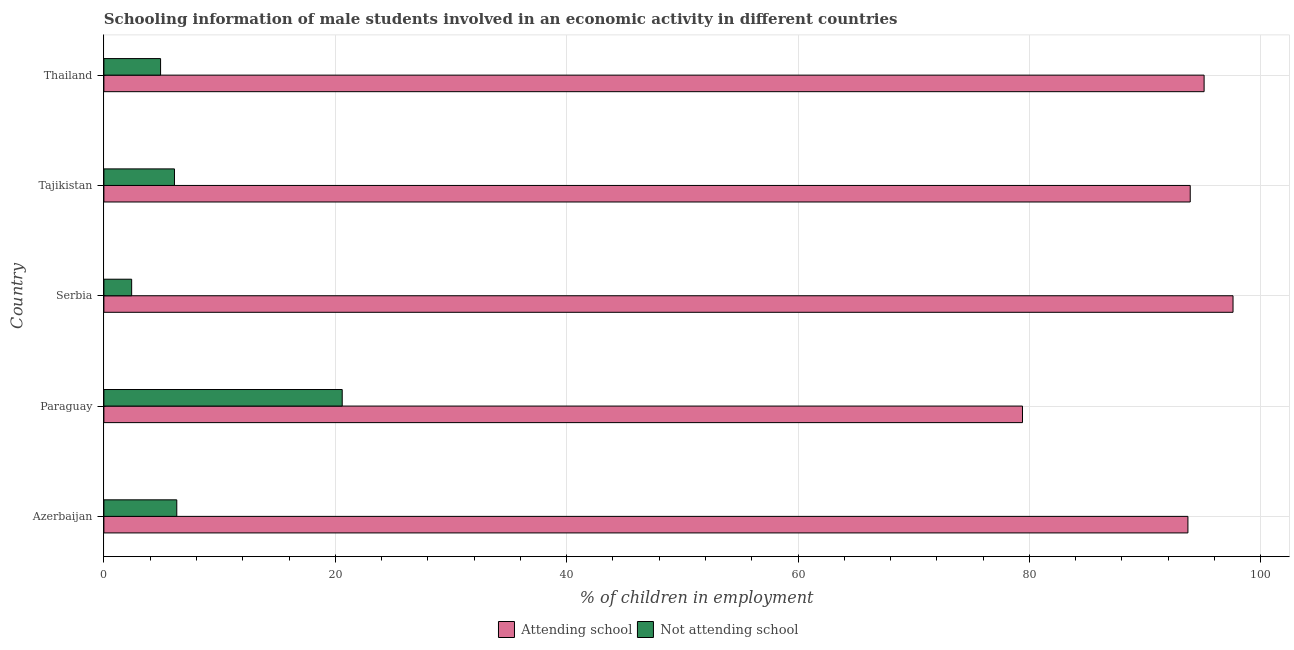How many different coloured bars are there?
Ensure brevity in your answer.  2. How many groups of bars are there?
Offer a terse response. 5. Are the number of bars on each tick of the Y-axis equal?
Offer a very short reply. Yes. How many bars are there on the 4th tick from the bottom?
Your answer should be very brief. 2. What is the label of the 3rd group of bars from the top?
Your response must be concise. Serbia. What is the percentage of employed males who are attending school in Azerbaijan?
Ensure brevity in your answer.  93.7. Across all countries, what is the maximum percentage of employed males who are not attending school?
Ensure brevity in your answer.  20.6. Across all countries, what is the minimum percentage of employed males who are attending school?
Offer a terse response. 79.4. In which country was the percentage of employed males who are attending school maximum?
Provide a succinct answer. Serbia. In which country was the percentage of employed males who are not attending school minimum?
Ensure brevity in your answer.  Serbia. What is the total percentage of employed males who are attending school in the graph?
Ensure brevity in your answer.  459.7. What is the difference between the percentage of employed males who are attending school in Azerbaijan and that in Tajikistan?
Offer a terse response. -0.2. What is the difference between the percentage of employed males who are not attending school in Azerbaijan and the percentage of employed males who are attending school in Paraguay?
Give a very brief answer. -73.1. What is the average percentage of employed males who are attending school per country?
Offer a terse response. 91.94. What is the difference between the percentage of employed males who are not attending school and percentage of employed males who are attending school in Tajikistan?
Provide a succinct answer. -87.8. What is the ratio of the percentage of employed males who are attending school in Paraguay to that in Serbia?
Make the answer very short. 0.81. Is the percentage of employed males who are not attending school in Azerbaijan less than that in Thailand?
Provide a succinct answer. No. In how many countries, is the percentage of employed males who are not attending school greater than the average percentage of employed males who are not attending school taken over all countries?
Provide a short and direct response. 1. What does the 2nd bar from the top in Thailand represents?
Your answer should be very brief. Attending school. What does the 2nd bar from the bottom in Azerbaijan represents?
Make the answer very short. Not attending school. How many bars are there?
Your response must be concise. 10. How many countries are there in the graph?
Your answer should be compact. 5. What is the difference between two consecutive major ticks on the X-axis?
Offer a very short reply. 20. How many legend labels are there?
Give a very brief answer. 2. How are the legend labels stacked?
Your response must be concise. Horizontal. What is the title of the graph?
Provide a succinct answer. Schooling information of male students involved in an economic activity in different countries. What is the label or title of the X-axis?
Your answer should be compact. % of children in employment. What is the % of children in employment of Attending school in Azerbaijan?
Your answer should be compact. 93.7. What is the % of children in employment of Not attending school in Azerbaijan?
Keep it short and to the point. 6.3. What is the % of children in employment in Attending school in Paraguay?
Give a very brief answer. 79.4. What is the % of children in employment of Not attending school in Paraguay?
Provide a short and direct response. 20.6. What is the % of children in employment of Attending school in Serbia?
Ensure brevity in your answer.  97.6. What is the % of children in employment in Not attending school in Serbia?
Offer a very short reply. 2.4. What is the % of children in employment in Attending school in Tajikistan?
Your answer should be very brief. 93.9. What is the % of children in employment of Attending school in Thailand?
Your response must be concise. 95.1. What is the % of children in employment of Not attending school in Thailand?
Make the answer very short. 4.9. Across all countries, what is the maximum % of children in employment of Attending school?
Offer a very short reply. 97.6. Across all countries, what is the maximum % of children in employment in Not attending school?
Ensure brevity in your answer.  20.6. Across all countries, what is the minimum % of children in employment in Attending school?
Ensure brevity in your answer.  79.4. Across all countries, what is the minimum % of children in employment in Not attending school?
Keep it short and to the point. 2.4. What is the total % of children in employment in Attending school in the graph?
Give a very brief answer. 459.7. What is the total % of children in employment in Not attending school in the graph?
Your answer should be compact. 40.3. What is the difference between the % of children in employment of Not attending school in Azerbaijan and that in Paraguay?
Your response must be concise. -14.3. What is the difference between the % of children in employment of Attending school in Azerbaijan and that in Serbia?
Offer a terse response. -3.9. What is the difference between the % of children in employment of Attending school in Azerbaijan and that in Tajikistan?
Give a very brief answer. -0.2. What is the difference between the % of children in employment of Not attending school in Azerbaijan and that in Tajikistan?
Keep it short and to the point. 0.2. What is the difference between the % of children in employment in Not attending school in Azerbaijan and that in Thailand?
Provide a succinct answer. 1.4. What is the difference between the % of children in employment of Attending school in Paraguay and that in Serbia?
Make the answer very short. -18.2. What is the difference between the % of children in employment of Attending school in Paraguay and that in Tajikistan?
Your answer should be very brief. -14.5. What is the difference between the % of children in employment in Not attending school in Paraguay and that in Tajikistan?
Make the answer very short. 14.5. What is the difference between the % of children in employment in Attending school in Paraguay and that in Thailand?
Your response must be concise. -15.7. What is the difference between the % of children in employment of Attending school in Serbia and that in Thailand?
Your answer should be compact. 2.5. What is the difference between the % of children in employment of Not attending school in Serbia and that in Thailand?
Your answer should be compact. -2.5. What is the difference between the % of children in employment of Attending school in Azerbaijan and the % of children in employment of Not attending school in Paraguay?
Provide a succinct answer. 73.1. What is the difference between the % of children in employment in Attending school in Azerbaijan and the % of children in employment in Not attending school in Serbia?
Your response must be concise. 91.3. What is the difference between the % of children in employment of Attending school in Azerbaijan and the % of children in employment of Not attending school in Tajikistan?
Keep it short and to the point. 87.6. What is the difference between the % of children in employment of Attending school in Azerbaijan and the % of children in employment of Not attending school in Thailand?
Make the answer very short. 88.8. What is the difference between the % of children in employment in Attending school in Paraguay and the % of children in employment in Not attending school in Tajikistan?
Offer a terse response. 73.3. What is the difference between the % of children in employment in Attending school in Paraguay and the % of children in employment in Not attending school in Thailand?
Your response must be concise. 74.5. What is the difference between the % of children in employment of Attending school in Serbia and the % of children in employment of Not attending school in Tajikistan?
Your response must be concise. 91.5. What is the difference between the % of children in employment of Attending school in Serbia and the % of children in employment of Not attending school in Thailand?
Provide a short and direct response. 92.7. What is the difference between the % of children in employment in Attending school in Tajikistan and the % of children in employment in Not attending school in Thailand?
Provide a short and direct response. 89. What is the average % of children in employment in Attending school per country?
Your answer should be compact. 91.94. What is the average % of children in employment in Not attending school per country?
Give a very brief answer. 8.06. What is the difference between the % of children in employment of Attending school and % of children in employment of Not attending school in Azerbaijan?
Ensure brevity in your answer.  87.4. What is the difference between the % of children in employment in Attending school and % of children in employment in Not attending school in Paraguay?
Offer a very short reply. 58.8. What is the difference between the % of children in employment of Attending school and % of children in employment of Not attending school in Serbia?
Offer a terse response. 95.2. What is the difference between the % of children in employment of Attending school and % of children in employment of Not attending school in Tajikistan?
Ensure brevity in your answer.  87.8. What is the difference between the % of children in employment in Attending school and % of children in employment in Not attending school in Thailand?
Offer a terse response. 90.2. What is the ratio of the % of children in employment in Attending school in Azerbaijan to that in Paraguay?
Your response must be concise. 1.18. What is the ratio of the % of children in employment of Not attending school in Azerbaijan to that in Paraguay?
Your answer should be compact. 0.31. What is the ratio of the % of children in employment in Attending school in Azerbaijan to that in Serbia?
Your answer should be compact. 0.96. What is the ratio of the % of children in employment of Not attending school in Azerbaijan to that in Serbia?
Ensure brevity in your answer.  2.62. What is the ratio of the % of children in employment in Attending school in Azerbaijan to that in Tajikistan?
Provide a succinct answer. 1. What is the ratio of the % of children in employment in Not attending school in Azerbaijan to that in Tajikistan?
Keep it short and to the point. 1.03. What is the ratio of the % of children in employment in Attending school in Azerbaijan to that in Thailand?
Your answer should be compact. 0.99. What is the ratio of the % of children in employment of Attending school in Paraguay to that in Serbia?
Ensure brevity in your answer.  0.81. What is the ratio of the % of children in employment of Not attending school in Paraguay to that in Serbia?
Your answer should be very brief. 8.58. What is the ratio of the % of children in employment of Attending school in Paraguay to that in Tajikistan?
Offer a very short reply. 0.85. What is the ratio of the % of children in employment in Not attending school in Paraguay to that in Tajikistan?
Make the answer very short. 3.38. What is the ratio of the % of children in employment in Attending school in Paraguay to that in Thailand?
Your answer should be compact. 0.83. What is the ratio of the % of children in employment of Not attending school in Paraguay to that in Thailand?
Provide a succinct answer. 4.2. What is the ratio of the % of children in employment in Attending school in Serbia to that in Tajikistan?
Your response must be concise. 1.04. What is the ratio of the % of children in employment in Not attending school in Serbia to that in Tajikistan?
Provide a succinct answer. 0.39. What is the ratio of the % of children in employment of Attending school in Serbia to that in Thailand?
Your answer should be compact. 1.03. What is the ratio of the % of children in employment in Not attending school in Serbia to that in Thailand?
Provide a succinct answer. 0.49. What is the ratio of the % of children in employment in Attending school in Tajikistan to that in Thailand?
Provide a short and direct response. 0.99. What is the ratio of the % of children in employment of Not attending school in Tajikistan to that in Thailand?
Offer a terse response. 1.24. What is the difference between the highest and the second highest % of children in employment in Attending school?
Give a very brief answer. 2.5. What is the difference between the highest and the second highest % of children in employment of Not attending school?
Offer a terse response. 14.3. What is the difference between the highest and the lowest % of children in employment of Not attending school?
Keep it short and to the point. 18.2. 